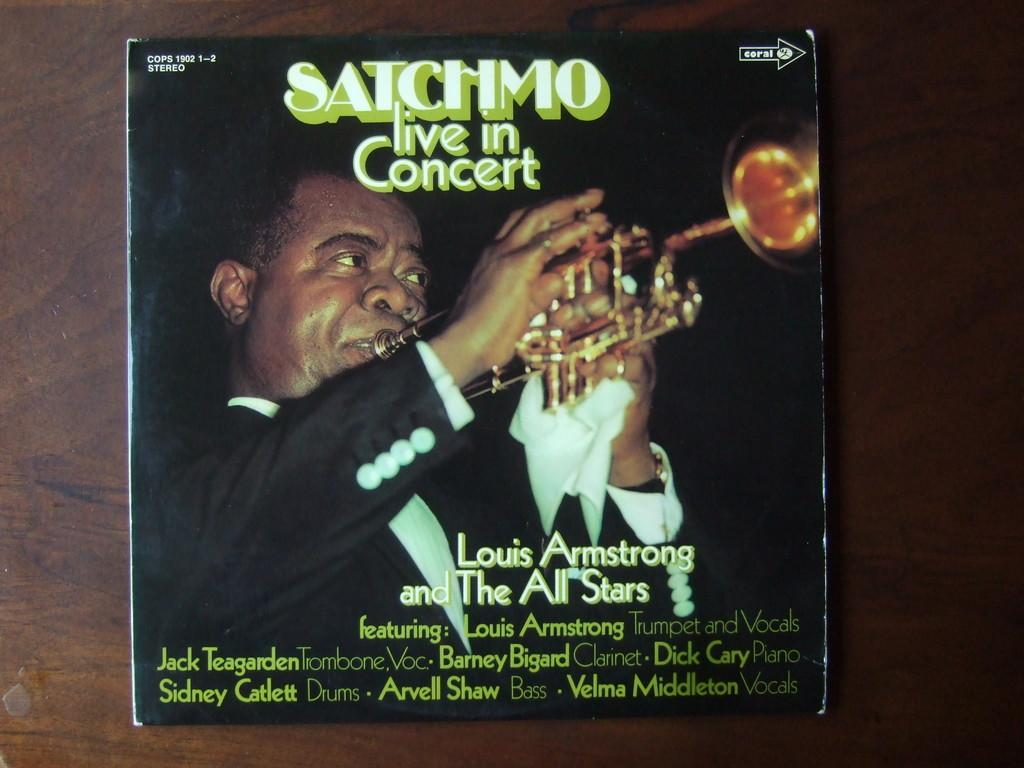What object is placed on the table in the image? There is a book placed on a table in the image. What is depicted on the cover of the book? The book has a picture of a person playing the trumpet. What else can be found on the book besides the image? There is text on the book. What type of sail can be seen in the image? There is no sail present in the image; it features a book with a picture of a person playing the trumpet. How many people are walking down the street in the image? There are no people walking down the street in the image; it features a book placed on a table. 